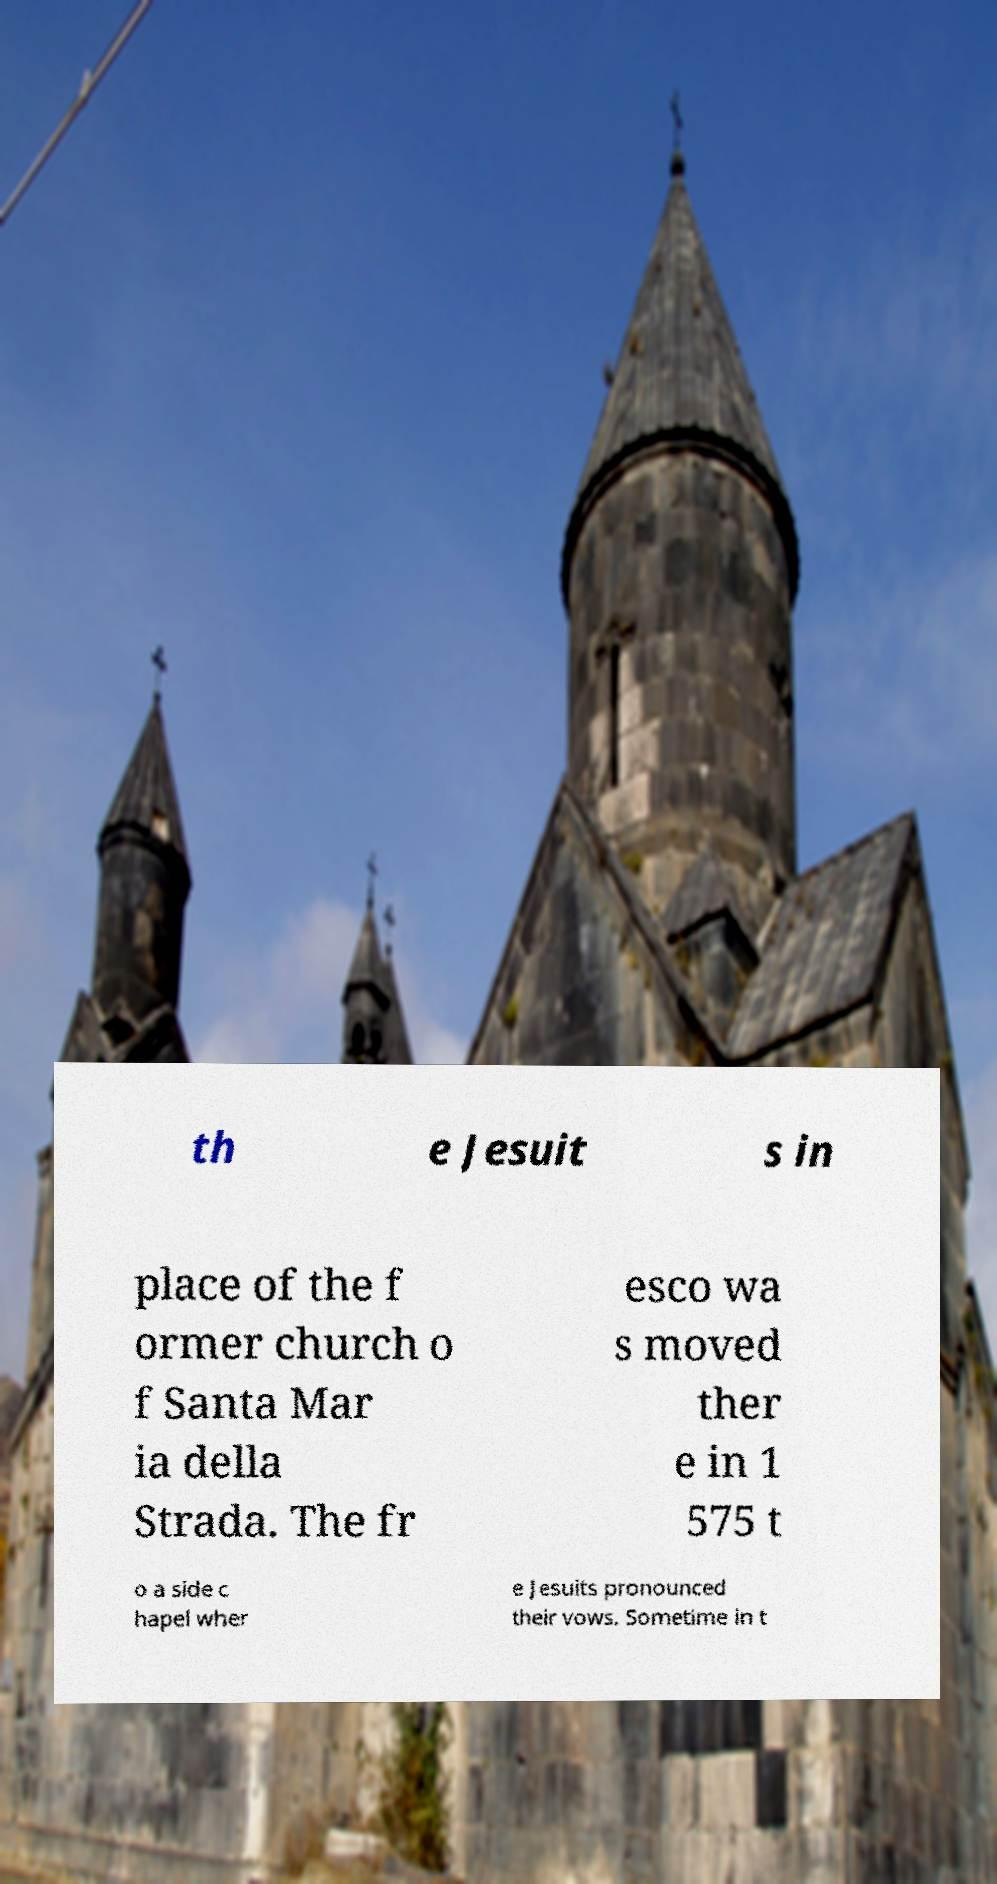For documentation purposes, I need the text within this image transcribed. Could you provide that? th e Jesuit s in place of the f ormer church o f Santa Mar ia della Strada. The fr esco wa s moved ther e in 1 575 t o a side c hapel wher e Jesuits pronounced their vows. Sometime in t 